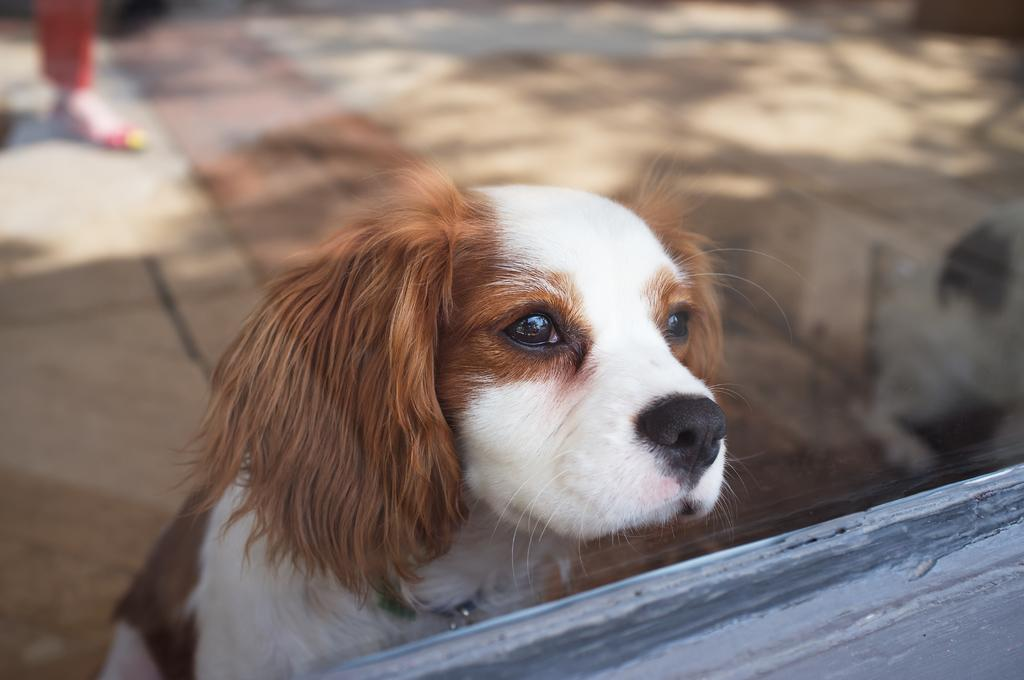What is the main subject in the center of the image? There is a dog in the center of the image. Can you describe anything in the background of the image? There is a person's leg in the background of the image. What type of surface is at the bottom of the image? There is a wooden surface at the bottom of the image. What type of fruit is being used to create a bubble in the image? There is no fruit or bubble present in the image. 